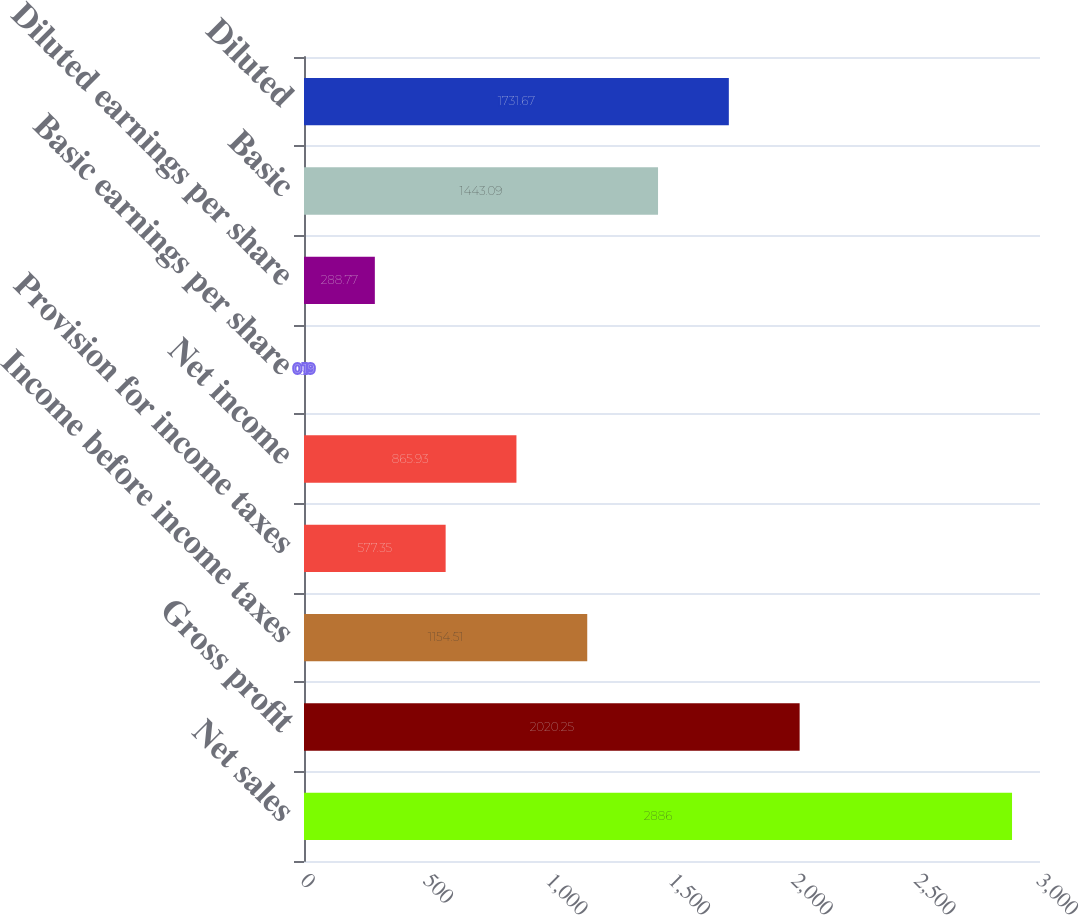<chart> <loc_0><loc_0><loc_500><loc_500><bar_chart><fcel>Net sales<fcel>Gross profit<fcel>Income before income taxes<fcel>Provision for income taxes<fcel>Net income<fcel>Basic earnings per share<fcel>Diluted earnings per share<fcel>Basic<fcel>Diluted<nl><fcel>2886<fcel>2020.25<fcel>1154.51<fcel>577.35<fcel>865.93<fcel>0.19<fcel>288.77<fcel>1443.09<fcel>1731.67<nl></chart> 